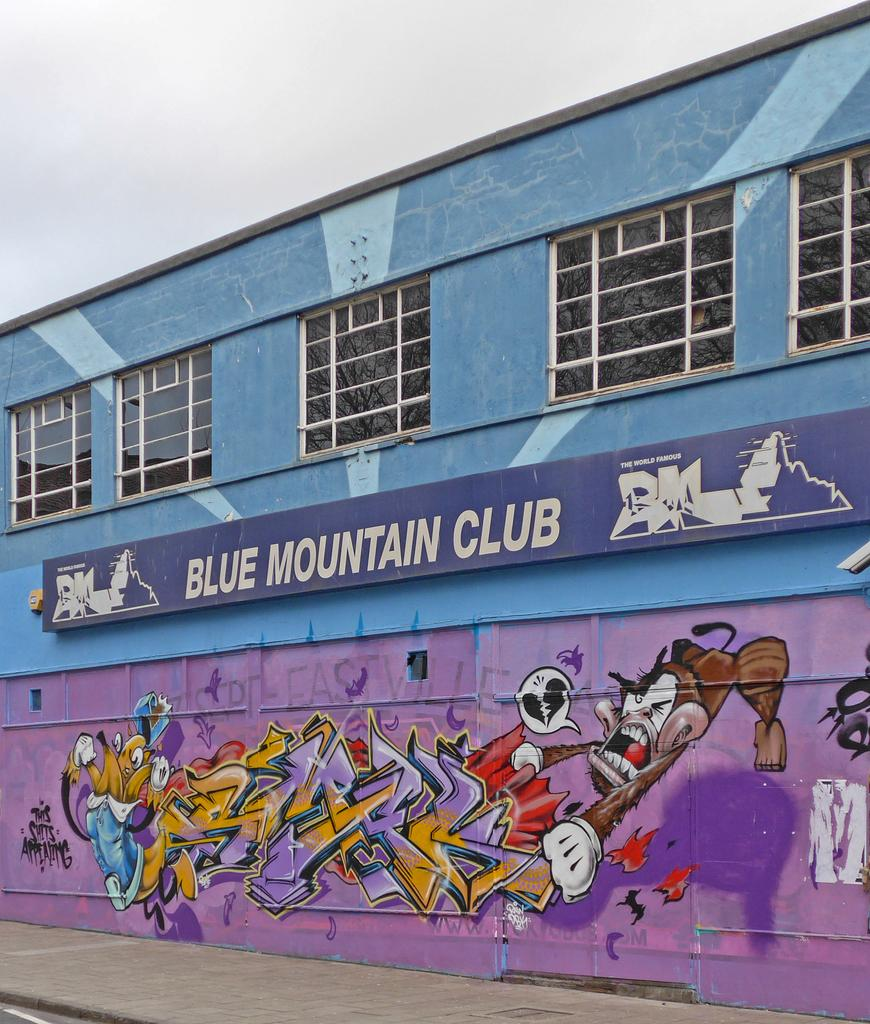<image>
Render a clear and concise summary of the photo. A sign that says Blue Mountain Club is above some graffeti art. 